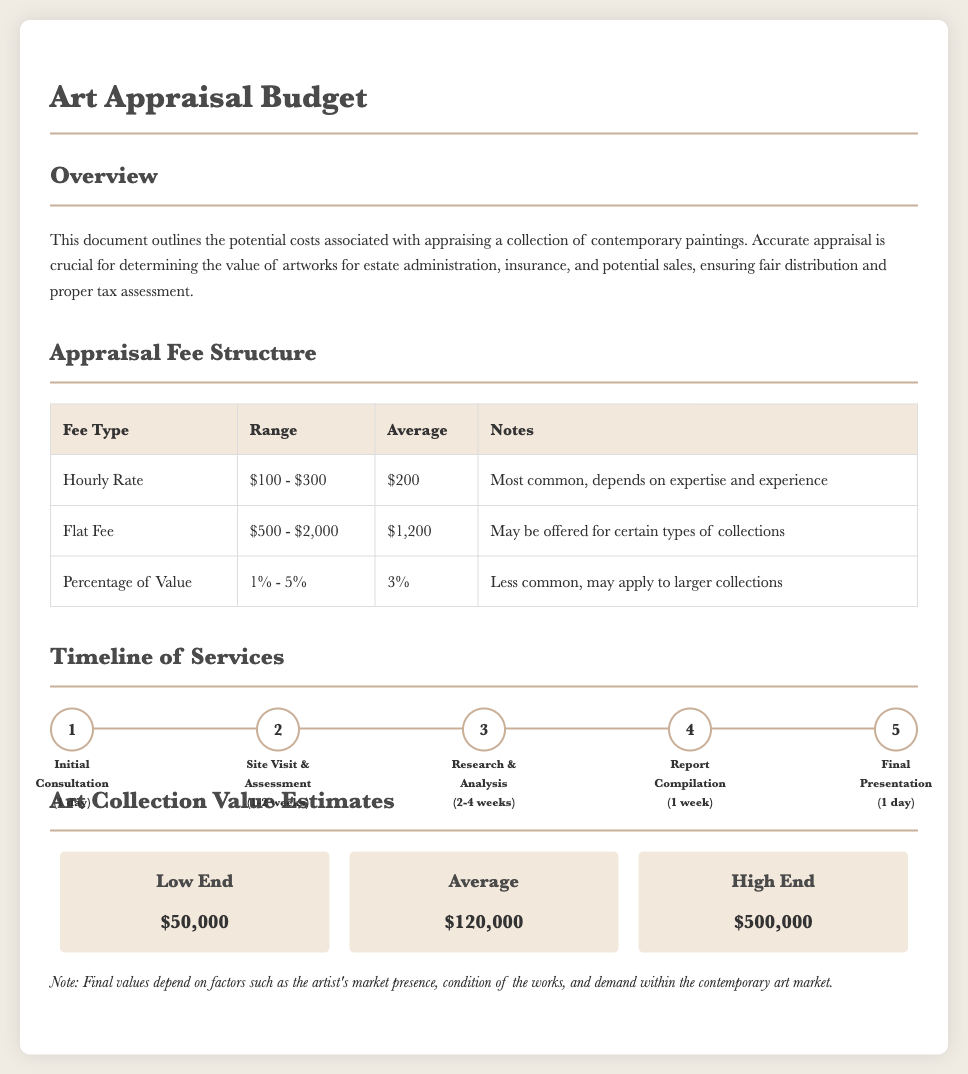What is the average hourly rate for appraisal? The average hourly rate for appraisal is stated in the fee structure section of the document.
Answer: $200 What is the timeline for the site visit and assessment? The timeline for the site visit and assessment is found in the timeline section of the document.
Answer: 1-2 weeks What is the low-end estimate for the art collection value? The low-end estimate is found in the art collection value estimates section of the document.
Answer: $50,000 What is the range for the flat fee? The range for the flat fee is mentioned in the appraisal fee structure table.
Answer: $500 - $2,000 How many stages are in the appraisal timeline? The number of stages in the appraisal timeline can be counted in the timeline section of the document.
Answer: 5 What percentage range might be used for large collections under the fee structure? The percentage range applied to larger collections is detailed in the fee structure section.
Answer: 1% - 5% What is included in the final presentation stage of the timeline? The final presentation stage is described in the timeline section of the document.
Answer: 1 day What is the average value estimate for the collection? The average value estimate is mentioned in the art collection value estimates section.
Answer: $120,000 What is the main purpose of the appraisal as stated in the overview? The main purpose of the appraisal is outlined in the first section of the document.
Answer: Valuing artworks for estate administration, insurance, and potential sales 